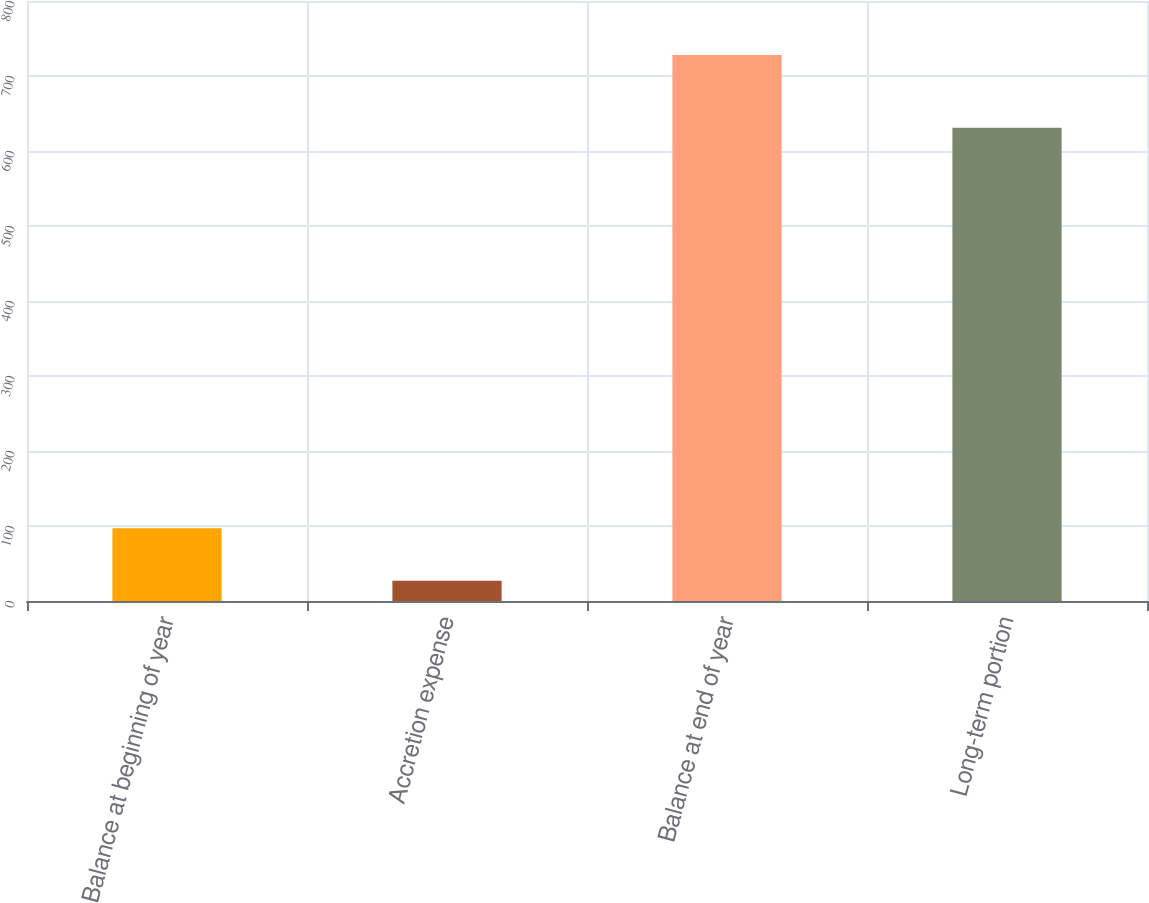<chart> <loc_0><loc_0><loc_500><loc_500><bar_chart><fcel>Balance at beginning of year<fcel>Accretion expense<fcel>Balance at end of year<fcel>Long-term portion<nl><fcel>97.1<fcel>27<fcel>728<fcel>631<nl></chart> 